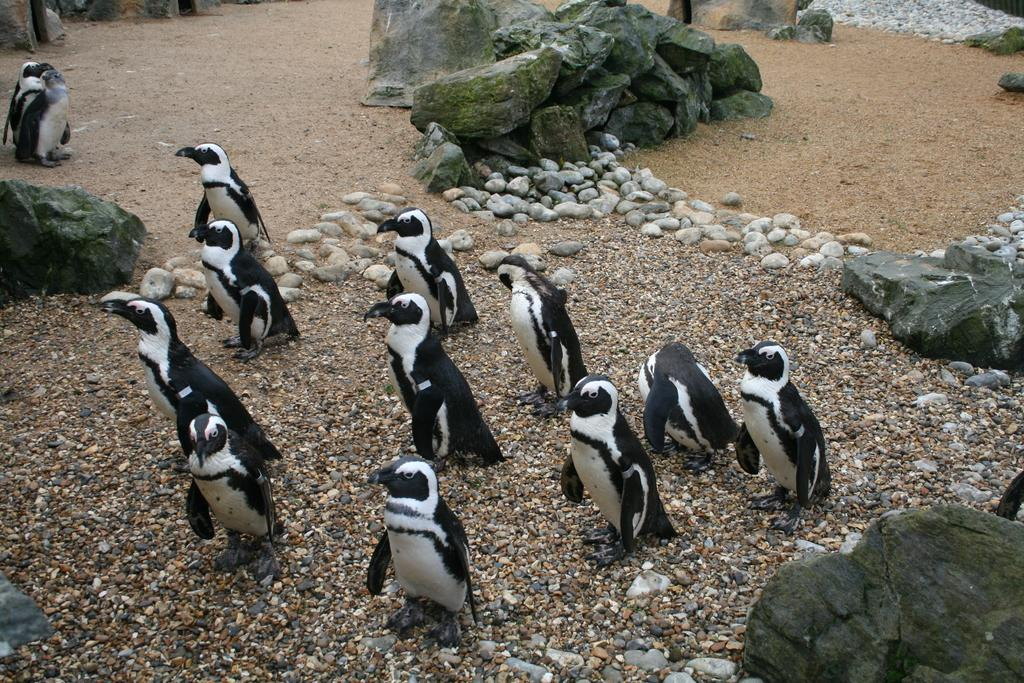What type of animals are present in the image? There are penguins in the image. What can be seen around the penguins in the image? There are big rocks around the penguins. What type of ship can be seen in the image? There is no ship present in the image; it features penguins and big rocks. What is the wealth status of the penguins in the image? The image does not provide any information about the wealth status of the penguins. 